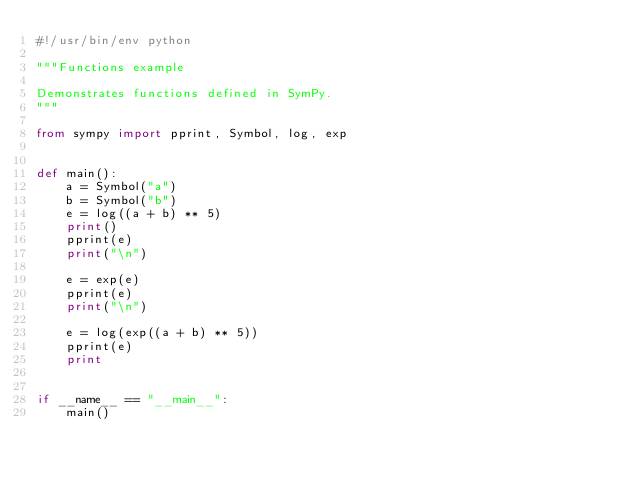<code> <loc_0><loc_0><loc_500><loc_500><_Python_>#!/usr/bin/env python

"""Functions example

Demonstrates functions defined in SymPy.
"""

from sympy import pprint, Symbol, log, exp


def main():
    a = Symbol("a")
    b = Symbol("b")
    e = log((a + b) ** 5)
    print()
    pprint(e)
    print("\n")

    e = exp(e)
    pprint(e)
    print("\n")

    e = log(exp((a + b) ** 5))
    pprint(e)
    print


if __name__ == "__main__":
    main()
</code> 